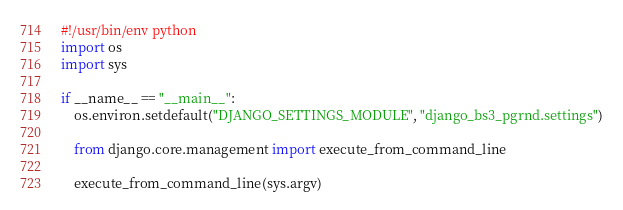Convert code to text. <code><loc_0><loc_0><loc_500><loc_500><_Python_>#!/usr/bin/env python
import os
import sys

if __name__ == "__main__":
    os.environ.setdefault("DJANGO_SETTINGS_MODULE", "django_bs3_pgrnd.settings")

    from django.core.management import execute_from_command_line

    execute_from_command_line(sys.argv)
</code> 